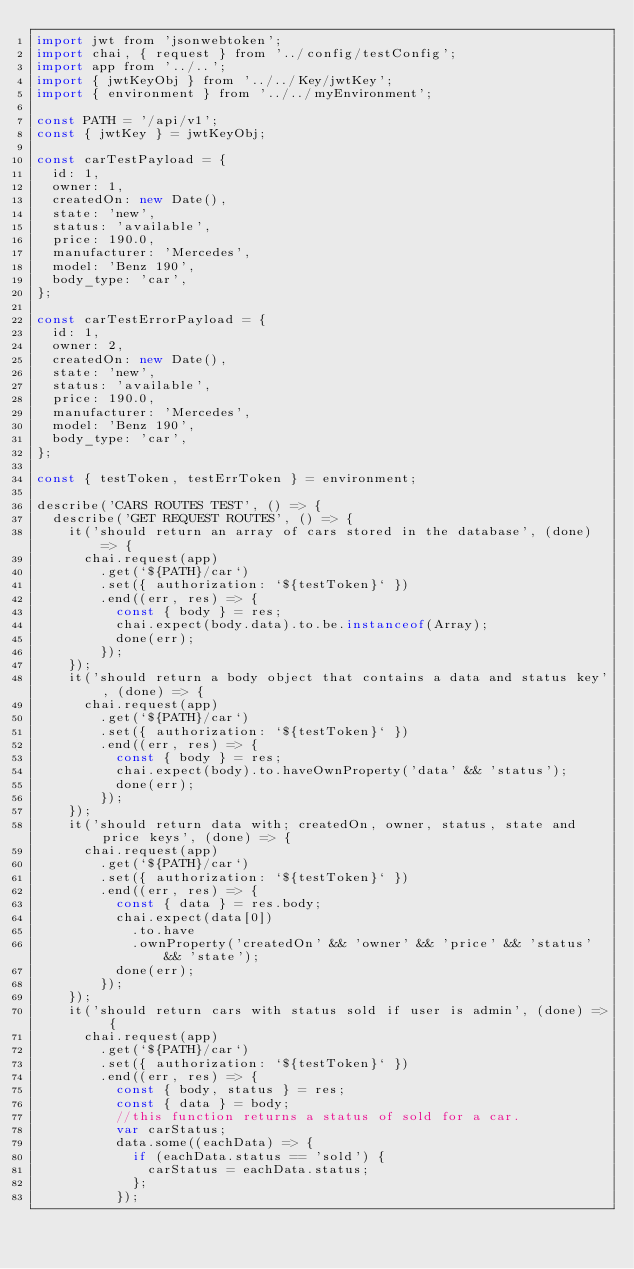Convert code to text. <code><loc_0><loc_0><loc_500><loc_500><_JavaScript_>import jwt from 'jsonwebtoken';
import chai, { request } from '../config/testConfig';
import app from '../..';
import { jwtKeyObj } from '../../Key/jwtKey';
import { environment } from '../../myEnvironment';

const PATH = '/api/v1';
const { jwtKey } = jwtKeyObj;

const carTestPayload = {
  id: 1,
  owner: 1,
  createdOn: new Date(),
  state: 'new',
  status: 'available',
  price: 190.0,
  manufacturer: 'Mercedes',
  model: 'Benz 190',
  body_type: 'car',
};

const carTestErrorPayload = {
  id: 1,
  owner: 2,
  createdOn: new Date(),
  state: 'new',
  status: 'available',
  price: 190.0,
  manufacturer: 'Mercedes',
  model: 'Benz 190',
  body_type: 'car',
};

const { testToken, testErrToken } = environment;

describe('CARS ROUTES TEST', () => {
  describe('GET REQUEST ROUTES', () => {
    it('should return an array of cars stored in the database', (done) => {
      chai.request(app)
        .get(`${PATH}/car`)
        .set({ authorization: `${testToken}` })
        .end((err, res) => {
          const { body } = res;
          chai.expect(body.data).to.be.instanceof(Array);
          done(err);
        });
    });
    it('should return a body object that contains a data and status key', (done) => {
      chai.request(app)
        .get(`${PATH}/car`)
        .set({ authorization: `${testToken}` })
        .end((err, res) => {
          const { body } = res;
          chai.expect(body).to.haveOwnProperty('data' && 'status');
          done(err);
        });
    });
    it('should return data with; createdOn, owner, status, state and price keys', (done) => {
      chai.request(app)
        .get(`${PATH}/car`)
        .set({ authorization: `${testToken}` })
        .end((err, res) => {
          const { data } = res.body;
          chai.expect(data[0])
            .to.have
            .ownProperty('createdOn' && 'owner' && 'price' && 'status' && 'state');
          done(err);
        });
    });
    it('should return cars with status sold if user is admin', (done) => {
      chai.request(app)
        .get(`${PATH}/car`)
        .set({ authorization: `${testToken}` })
        .end((err, res) => {
          const { body, status } = res;
          const { data } = body;
          //this function returns a status of sold for a car.
          var carStatus;
          data.some((eachData) => {
            if (eachData.status == 'sold') {
              carStatus = eachData.status;
            };
          });</code> 